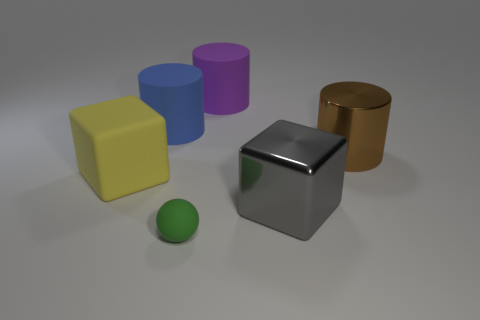Can you describe the texture of the objects? Certainly! The objects appear to have different textures: the yellow, blue, and purple objects have a matte surface, while the silver cube has a shiny, reflective surface. The green sphere has a smooth texture, and the brown cylinder looks like it has a rough or brushed metal texture. 